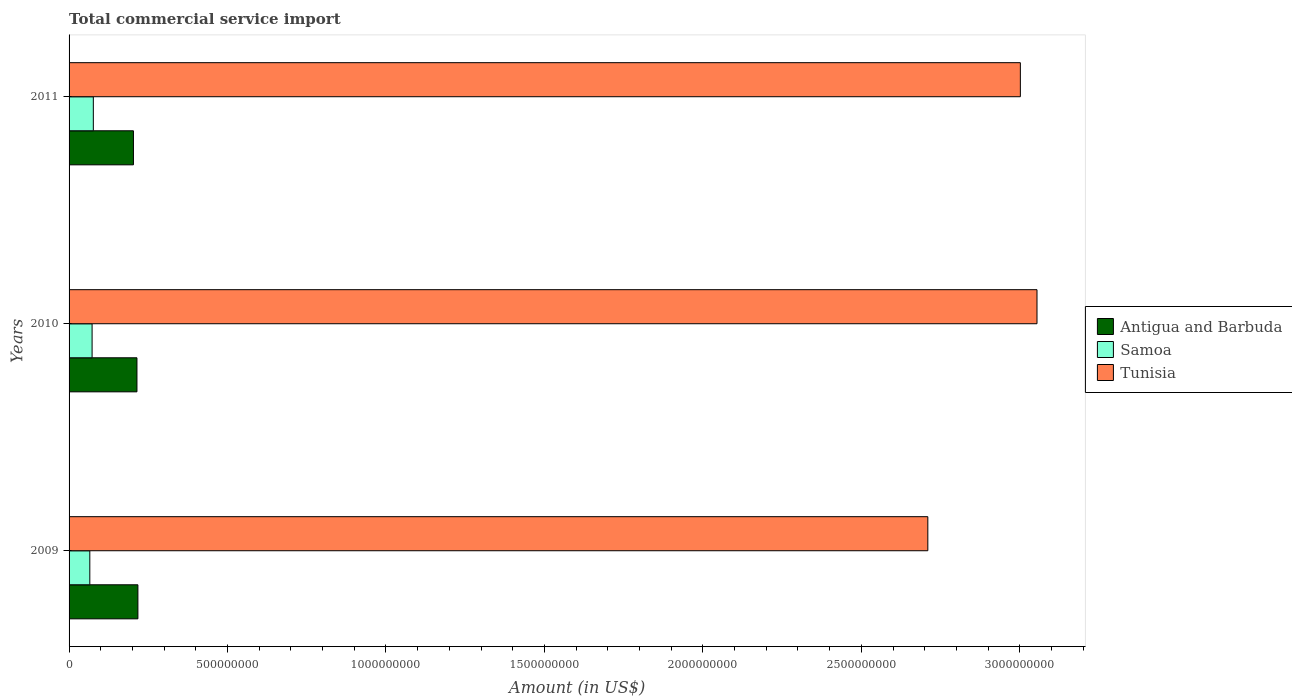How many groups of bars are there?
Make the answer very short. 3. How many bars are there on the 2nd tick from the top?
Your answer should be very brief. 3. What is the total commercial service import in Antigua and Barbuda in 2010?
Keep it short and to the point. 2.14e+08. Across all years, what is the maximum total commercial service import in Antigua and Barbuda?
Provide a succinct answer. 2.17e+08. Across all years, what is the minimum total commercial service import in Antigua and Barbuda?
Your answer should be very brief. 2.03e+08. What is the total total commercial service import in Samoa in the graph?
Keep it short and to the point. 2.15e+08. What is the difference between the total commercial service import in Antigua and Barbuda in 2009 and that in 2011?
Your response must be concise. 1.41e+07. What is the difference between the total commercial service import in Tunisia in 2009 and the total commercial service import in Samoa in 2011?
Make the answer very short. 2.63e+09. What is the average total commercial service import in Tunisia per year?
Keep it short and to the point. 2.92e+09. In the year 2011, what is the difference between the total commercial service import in Tunisia and total commercial service import in Antigua and Barbuda?
Keep it short and to the point. 2.80e+09. What is the ratio of the total commercial service import in Antigua and Barbuda in 2009 to that in 2011?
Make the answer very short. 1.07. What is the difference between the highest and the second highest total commercial service import in Antigua and Barbuda?
Make the answer very short. 2.99e+06. What is the difference between the highest and the lowest total commercial service import in Samoa?
Offer a very short reply. 1.11e+07. What does the 2nd bar from the top in 2011 represents?
Ensure brevity in your answer.  Samoa. What does the 1st bar from the bottom in 2011 represents?
Provide a short and direct response. Antigua and Barbuda. Are all the bars in the graph horizontal?
Give a very brief answer. Yes. How many years are there in the graph?
Offer a very short reply. 3. How are the legend labels stacked?
Offer a very short reply. Vertical. What is the title of the graph?
Your answer should be compact. Total commercial service import. Does "Mali" appear as one of the legend labels in the graph?
Provide a short and direct response. No. What is the label or title of the X-axis?
Provide a short and direct response. Amount (in US$). What is the Amount (in US$) in Antigua and Barbuda in 2009?
Make the answer very short. 2.17e+08. What is the Amount (in US$) of Samoa in 2009?
Provide a succinct answer. 6.55e+07. What is the Amount (in US$) in Tunisia in 2009?
Keep it short and to the point. 2.71e+09. What is the Amount (in US$) of Antigua and Barbuda in 2010?
Make the answer very short. 2.14e+08. What is the Amount (in US$) of Samoa in 2010?
Ensure brevity in your answer.  7.26e+07. What is the Amount (in US$) in Tunisia in 2010?
Ensure brevity in your answer.  3.05e+09. What is the Amount (in US$) of Antigua and Barbuda in 2011?
Your answer should be very brief. 2.03e+08. What is the Amount (in US$) in Samoa in 2011?
Your answer should be compact. 7.65e+07. What is the Amount (in US$) in Tunisia in 2011?
Your answer should be very brief. 3.00e+09. Across all years, what is the maximum Amount (in US$) in Antigua and Barbuda?
Offer a terse response. 2.17e+08. Across all years, what is the maximum Amount (in US$) in Samoa?
Your response must be concise. 7.65e+07. Across all years, what is the maximum Amount (in US$) of Tunisia?
Offer a terse response. 3.05e+09. Across all years, what is the minimum Amount (in US$) in Antigua and Barbuda?
Your answer should be very brief. 2.03e+08. Across all years, what is the minimum Amount (in US$) of Samoa?
Offer a very short reply. 6.55e+07. Across all years, what is the minimum Amount (in US$) in Tunisia?
Provide a short and direct response. 2.71e+09. What is the total Amount (in US$) of Antigua and Barbuda in the graph?
Provide a succinct answer. 6.35e+08. What is the total Amount (in US$) of Samoa in the graph?
Provide a short and direct response. 2.15e+08. What is the total Amount (in US$) in Tunisia in the graph?
Give a very brief answer. 8.77e+09. What is the difference between the Amount (in US$) in Antigua and Barbuda in 2009 and that in 2010?
Your response must be concise. 2.99e+06. What is the difference between the Amount (in US$) in Samoa in 2009 and that in 2010?
Your answer should be very brief. -7.18e+06. What is the difference between the Amount (in US$) of Tunisia in 2009 and that in 2010?
Make the answer very short. -3.45e+08. What is the difference between the Amount (in US$) of Antigua and Barbuda in 2009 and that in 2011?
Offer a terse response. 1.41e+07. What is the difference between the Amount (in US$) of Samoa in 2009 and that in 2011?
Provide a succinct answer. -1.11e+07. What is the difference between the Amount (in US$) of Tunisia in 2009 and that in 2011?
Make the answer very short. -2.92e+08. What is the difference between the Amount (in US$) in Antigua and Barbuda in 2010 and that in 2011?
Your answer should be compact. 1.11e+07. What is the difference between the Amount (in US$) of Samoa in 2010 and that in 2011?
Your answer should be very brief. -3.89e+06. What is the difference between the Amount (in US$) in Tunisia in 2010 and that in 2011?
Your answer should be compact. 5.25e+07. What is the difference between the Amount (in US$) of Antigua and Barbuda in 2009 and the Amount (in US$) of Samoa in 2010?
Your response must be concise. 1.45e+08. What is the difference between the Amount (in US$) of Antigua and Barbuda in 2009 and the Amount (in US$) of Tunisia in 2010?
Provide a succinct answer. -2.84e+09. What is the difference between the Amount (in US$) of Samoa in 2009 and the Amount (in US$) of Tunisia in 2010?
Your response must be concise. -2.99e+09. What is the difference between the Amount (in US$) of Antigua and Barbuda in 2009 and the Amount (in US$) of Samoa in 2011?
Provide a short and direct response. 1.41e+08. What is the difference between the Amount (in US$) of Antigua and Barbuda in 2009 and the Amount (in US$) of Tunisia in 2011?
Provide a short and direct response. -2.78e+09. What is the difference between the Amount (in US$) in Samoa in 2009 and the Amount (in US$) in Tunisia in 2011?
Offer a very short reply. -2.94e+09. What is the difference between the Amount (in US$) in Antigua and Barbuda in 2010 and the Amount (in US$) in Samoa in 2011?
Your answer should be very brief. 1.38e+08. What is the difference between the Amount (in US$) of Antigua and Barbuda in 2010 and the Amount (in US$) of Tunisia in 2011?
Provide a succinct answer. -2.79e+09. What is the difference between the Amount (in US$) in Samoa in 2010 and the Amount (in US$) in Tunisia in 2011?
Give a very brief answer. -2.93e+09. What is the average Amount (in US$) of Antigua and Barbuda per year?
Provide a short and direct response. 2.12e+08. What is the average Amount (in US$) of Samoa per year?
Ensure brevity in your answer.  7.15e+07. What is the average Amount (in US$) of Tunisia per year?
Make the answer very short. 2.92e+09. In the year 2009, what is the difference between the Amount (in US$) of Antigua and Barbuda and Amount (in US$) of Samoa?
Provide a short and direct response. 1.52e+08. In the year 2009, what is the difference between the Amount (in US$) of Antigua and Barbuda and Amount (in US$) of Tunisia?
Offer a terse response. -2.49e+09. In the year 2009, what is the difference between the Amount (in US$) of Samoa and Amount (in US$) of Tunisia?
Give a very brief answer. -2.64e+09. In the year 2010, what is the difference between the Amount (in US$) in Antigua and Barbuda and Amount (in US$) in Samoa?
Give a very brief answer. 1.42e+08. In the year 2010, what is the difference between the Amount (in US$) in Antigua and Barbuda and Amount (in US$) in Tunisia?
Ensure brevity in your answer.  -2.84e+09. In the year 2010, what is the difference between the Amount (in US$) in Samoa and Amount (in US$) in Tunisia?
Make the answer very short. -2.98e+09. In the year 2011, what is the difference between the Amount (in US$) in Antigua and Barbuda and Amount (in US$) in Samoa?
Your answer should be very brief. 1.27e+08. In the year 2011, what is the difference between the Amount (in US$) of Antigua and Barbuda and Amount (in US$) of Tunisia?
Your answer should be compact. -2.80e+09. In the year 2011, what is the difference between the Amount (in US$) in Samoa and Amount (in US$) in Tunisia?
Provide a short and direct response. -2.93e+09. What is the ratio of the Amount (in US$) in Antigua and Barbuda in 2009 to that in 2010?
Your response must be concise. 1.01. What is the ratio of the Amount (in US$) in Samoa in 2009 to that in 2010?
Offer a terse response. 0.9. What is the ratio of the Amount (in US$) in Tunisia in 2009 to that in 2010?
Offer a terse response. 0.89. What is the ratio of the Amount (in US$) in Antigua and Barbuda in 2009 to that in 2011?
Your answer should be very brief. 1.07. What is the ratio of the Amount (in US$) of Samoa in 2009 to that in 2011?
Your answer should be compact. 0.86. What is the ratio of the Amount (in US$) in Tunisia in 2009 to that in 2011?
Provide a succinct answer. 0.9. What is the ratio of the Amount (in US$) in Antigua and Barbuda in 2010 to that in 2011?
Offer a very short reply. 1.05. What is the ratio of the Amount (in US$) in Samoa in 2010 to that in 2011?
Provide a succinct answer. 0.95. What is the ratio of the Amount (in US$) in Tunisia in 2010 to that in 2011?
Offer a terse response. 1.02. What is the difference between the highest and the second highest Amount (in US$) of Antigua and Barbuda?
Offer a very short reply. 2.99e+06. What is the difference between the highest and the second highest Amount (in US$) in Samoa?
Your answer should be compact. 3.89e+06. What is the difference between the highest and the second highest Amount (in US$) in Tunisia?
Make the answer very short. 5.25e+07. What is the difference between the highest and the lowest Amount (in US$) of Antigua and Barbuda?
Your answer should be very brief. 1.41e+07. What is the difference between the highest and the lowest Amount (in US$) in Samoa?
Keep it short and to the point. 1.11e+07. What is the difference between the highest and the lowest Amount (in US$) of Tunisia?
Ensure brevity in your answer.  3.45e+08. 